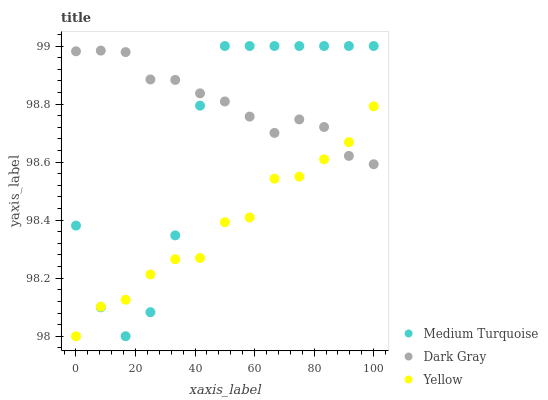Does Yellow have the minimum area under the curve?
Answer yes or no. Yes. Does Dark Gray have the maximum area under the curve?
Answer yes or no. Yes. Does Medium Turquoise have the minimum area under the curve?
Answer yes or no. No. Does Medium Turquoise have the maximum area under the curve?
Answer yes or no. No. Is Dark Gray the smoothest?
Answer yes or no. Yes. Is Medium Turquoise the roughest?
Answer yes or no. Yes. Is Yellow the smoothest?
Answer yes or no. No. Is Yellow the roughest?
Answer yes or no. No. Does Yellow have the lowest value?
Answer yes or no. Yes. Does Medium Turquoise have the lowest value?
Answer yes or no. No. Does Medium Turquoise have the highest value?
Answer yes or no. Yes. Does Yellow have the highest value?
Answer yes or no. No. Does Yellow intersect Medium Turquoise?
Answer yes or no. Yes. Is Yellow less than Medium Turquoise?
Answer yes or no. No. Is Yellow greater than Medium Turquoise?
Answer yes or no. No. 